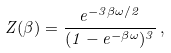Convert formula to latex. <formula><loc_0><loc_0><loc_500><loc_500>Z ( \beta ) = \frac { e ^ { - 3 \beta \omega / 2 } } { ( 1 - e ^ { - \beta \omega } ) ^ { 3 } } \, ,</formula> 